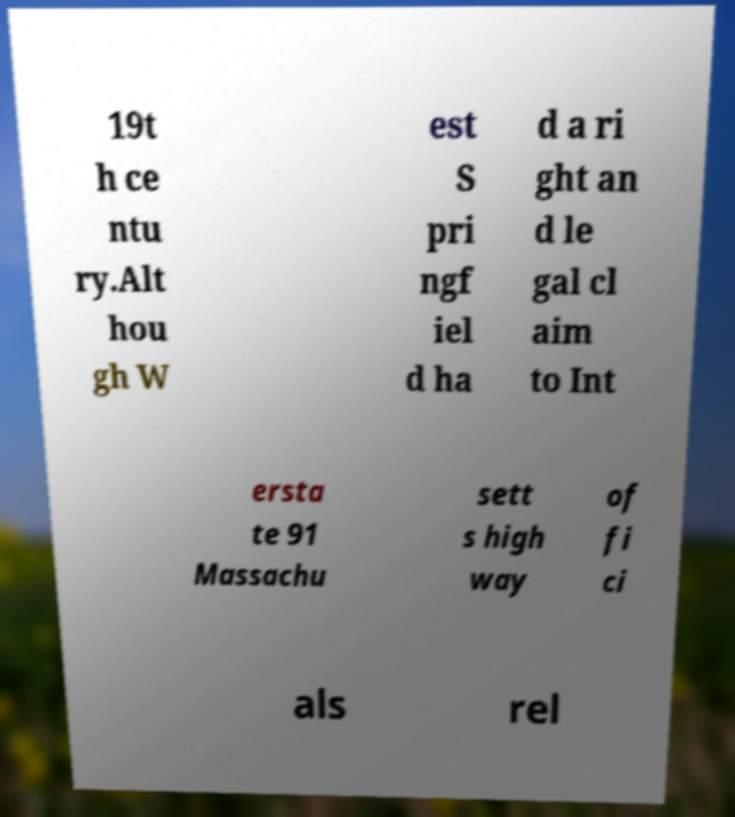Could you extract and type out the text from this image? 19t h ce ntu ry.Alt hou gh W est S pri ngf iel d ha d a ri ght an d le gal cl aim to Int ersta te 91 Massachu sett s high way of fi ci als rel 